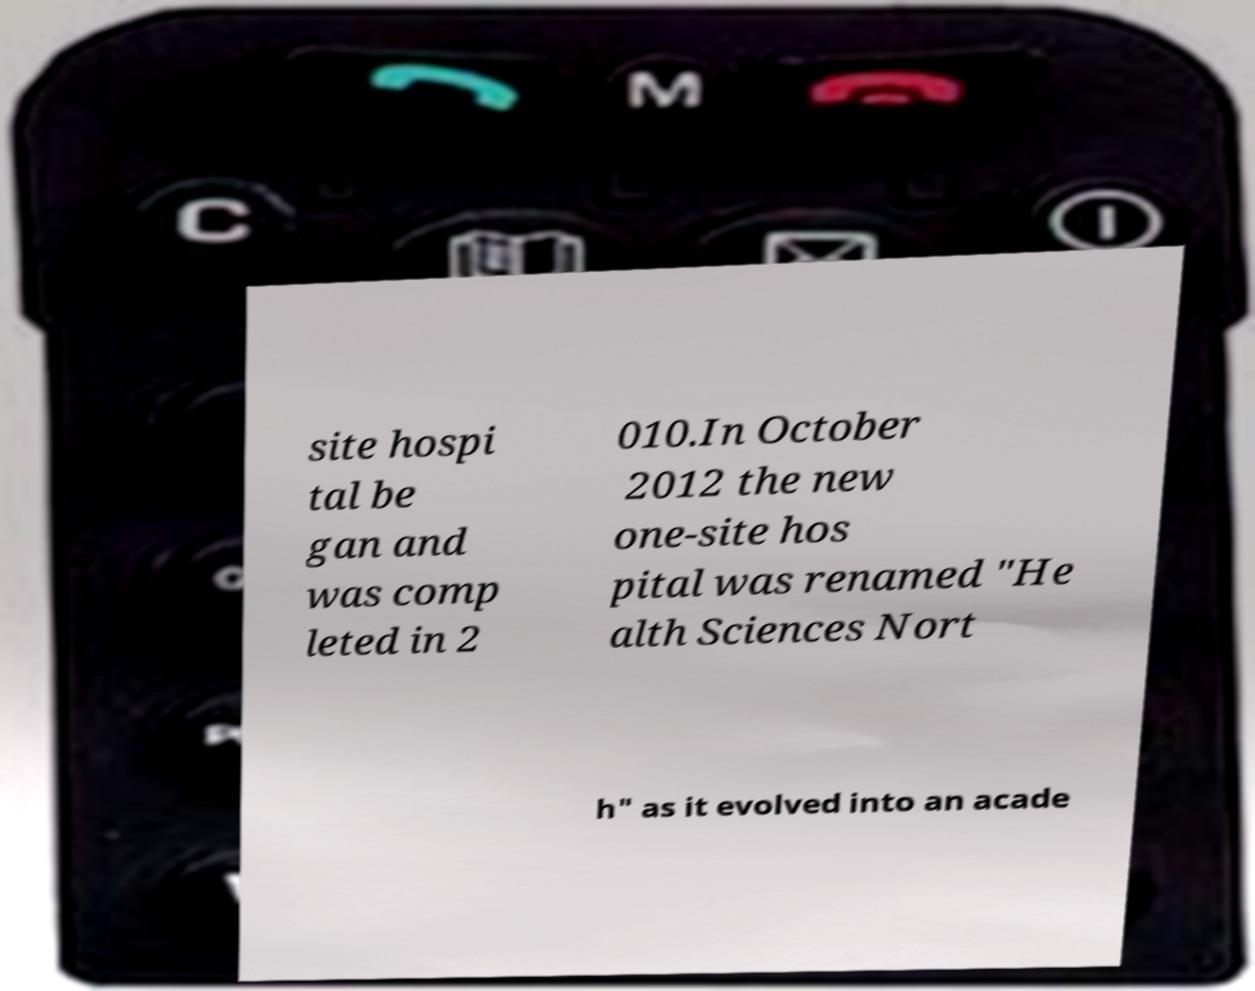What messages or text are displayed in this image? I need them in a readable, typed format. site hospi tal be gan and was comp leted in 2 010.In October 2012 the new one-site hos pital was renamed "He alth Sciences Nort h" as it evolved into an acade 